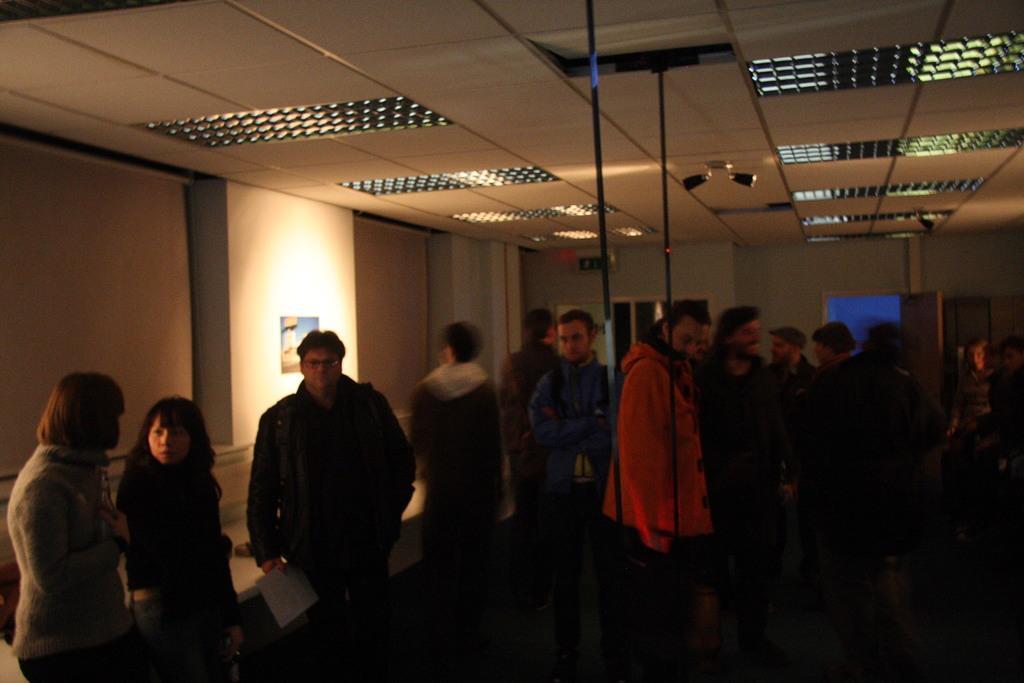Could you give a brief overview of what you see in this image? In this picture we can observe some people standing on the floor. There are men and women. We can observe a photo frame fixed to the wall on the left side. In the background there is a screen fixed to the wall. 